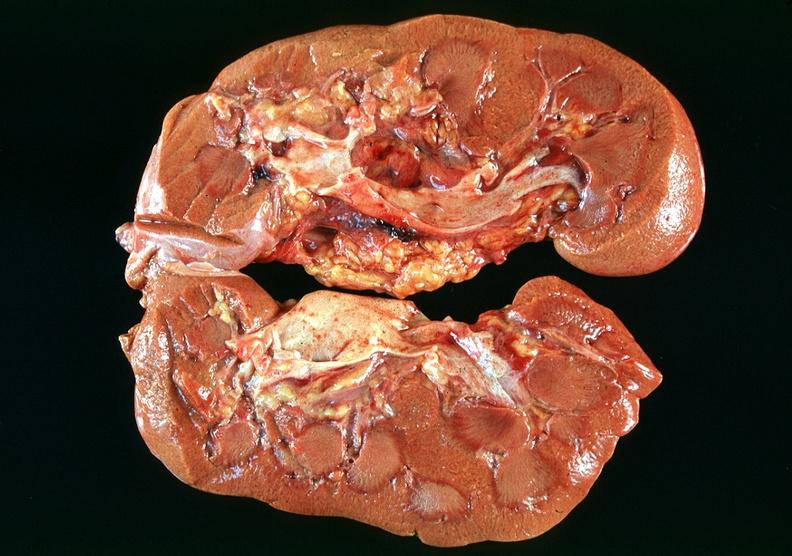where is this?
Answer the question using a single word or phrase. Urinary 